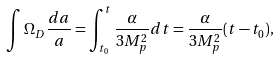<formula> <loc_0><loc_0><loc_500><loc_500>\int { \Omega _ { D } \frac { d a } { a } } = \int ^ { t } _ { t _ { 0 } } { \frac { \alpha } { 3 M _ { p } ^ { 2 } } d t } = \frac { \alpha } { 3 M _ { p } ^ { 2 } } ( t - t _ { 0 } ) ,</formula> 